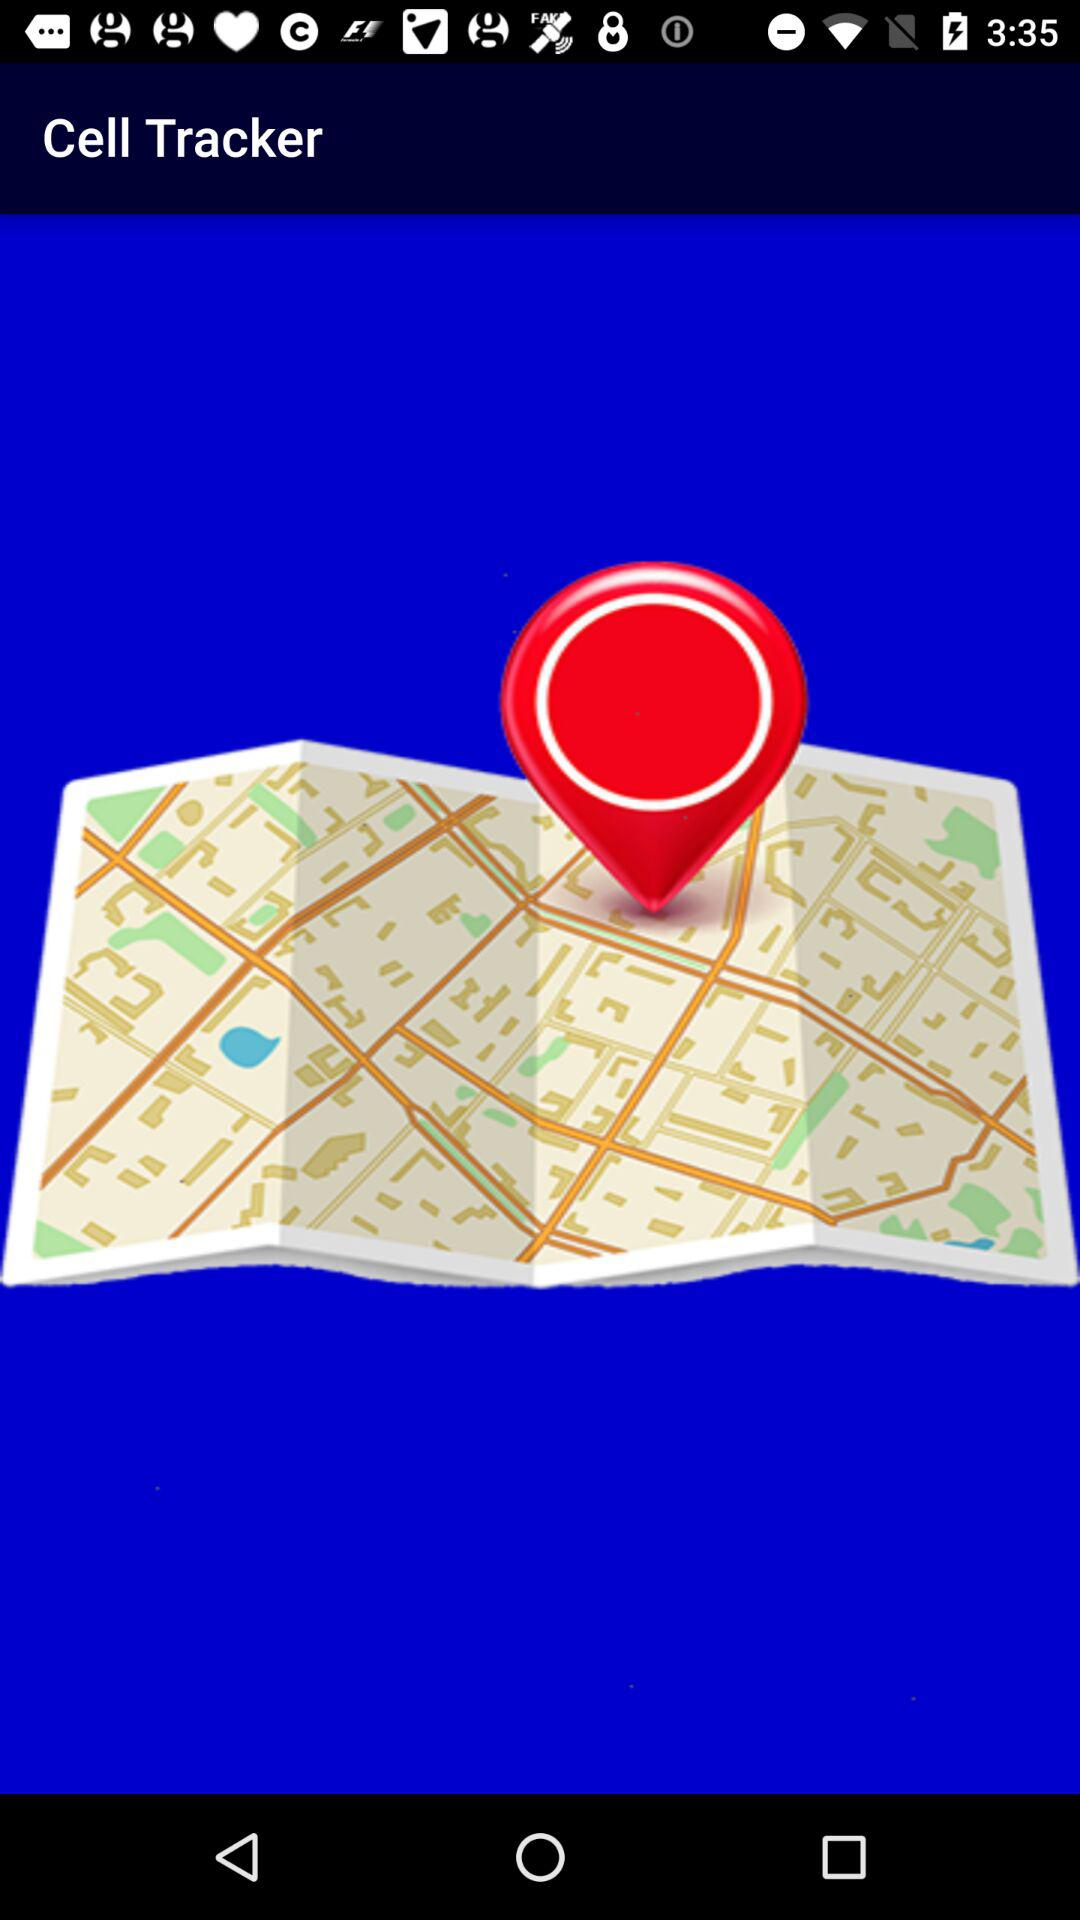What is the name of the application? The name of the application is "Cell Tracker". 